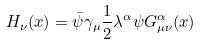Convert formula to latex. <formula><loc_0><loc_0><loc_500><loc_500>H _ { \nu } ( x ) = \bar { \psi } \gamma _ { \mu } \frac { 1 } { 2 } \lambda ^ { \alpha } \psi G _ { \mu \nu } ^ { \alpha } ( x )</formula> 